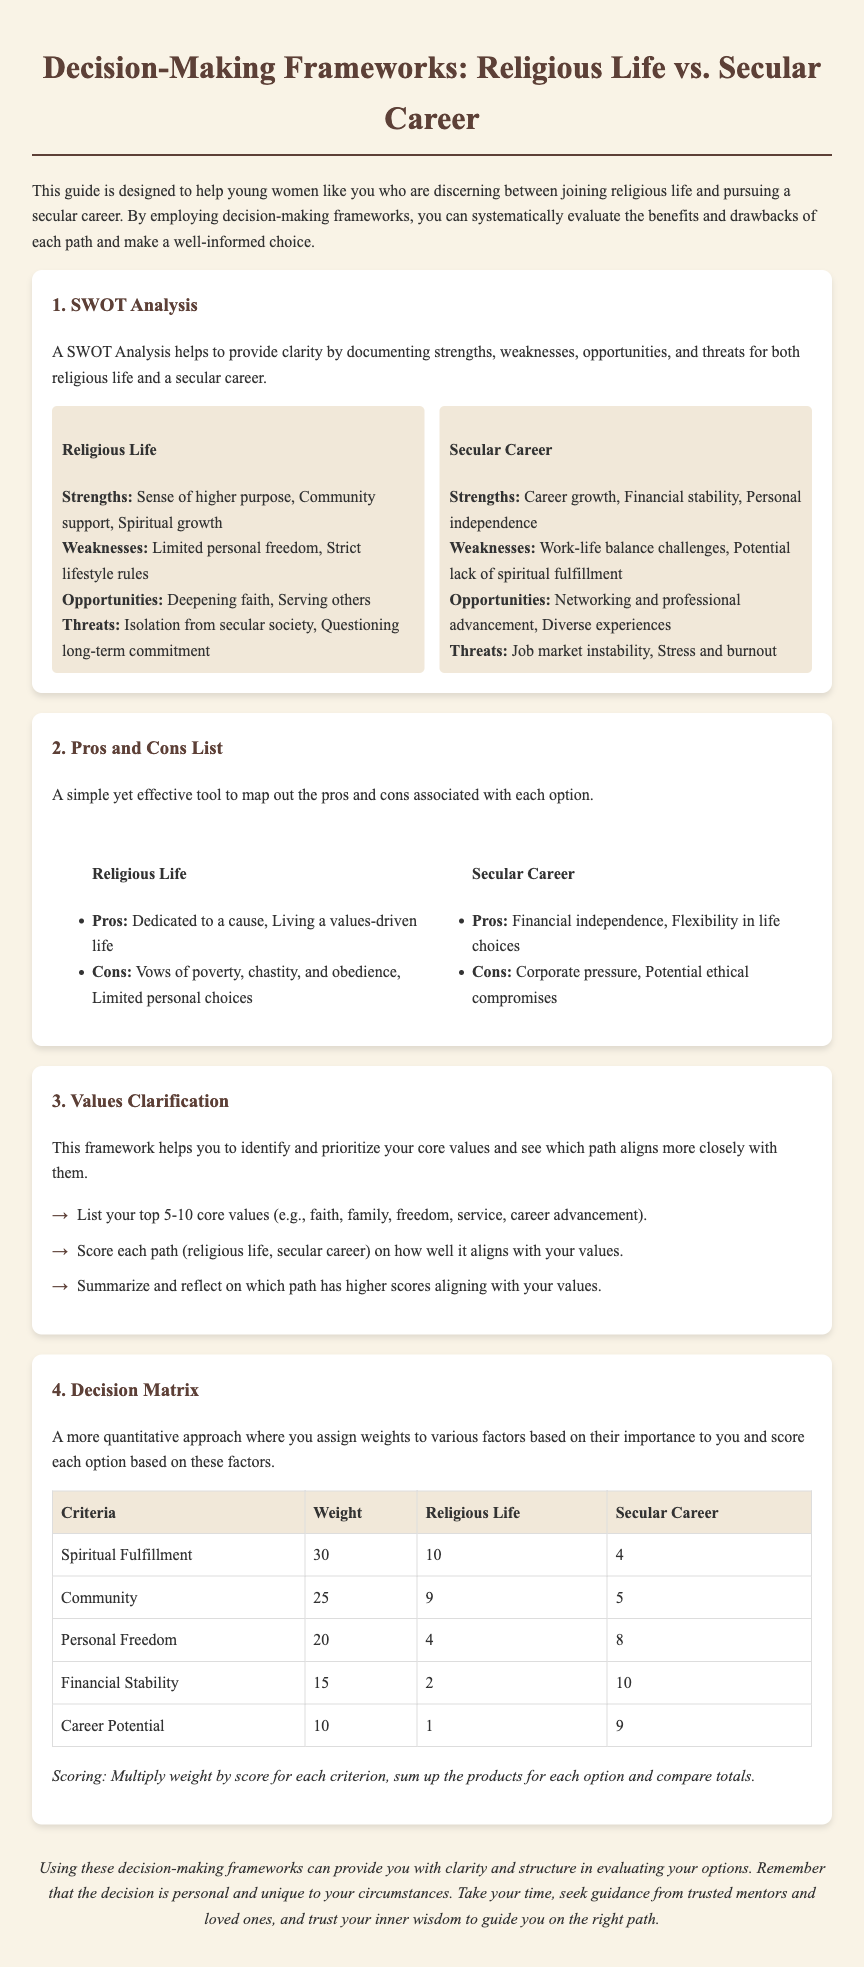What is the first decision-making framework mentioned? The document introduces the SWOT Analysis as the first framework to evaluate options.
Answer: SWOT Analysis What is one strength of a secular career? The document lists career growth as a strength of pursuing a secular career.
Answer: Career growth What score did the religious life receive for spiritual fulfillment? The document indicates a score of 10 for spiritual fulfillment associated with religious life.
Answer: 10 Which option has a higher score for personal freedom? Comparing the scores reveals that a secular career has a higher score (8) than religious life (4) for personal freedom.
Answer: Secular Career What is the weight assigned to community? The table assigns a weight of 25 to the community criterion.
Answer: 25 What are the vows associated with religious life? The document notes vows of poverty, chastity, and obedience related to religious life.
Answer: Poverty, chastity, and obedience What is the focus of the Values Clarification framework? This framework helps in identifying and prioritizing core values to evaluate alignment with each path.
Answer: Identifying and prioritizing core values How many criteria are evaluated in the Decision Matrix? The Decision Matrix evaluates 5 criteria based on importance to the individual.
Answer: 5 What conclusion does the document suggest about decision-making? The document concludes that using these frameworks can provide clarity and structure in evaluating options.
Answer: Clarity and structure 